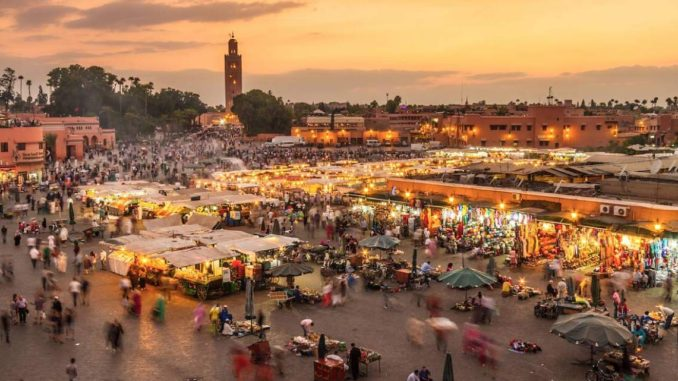Imagine you're standing in the middle of the market at night. Describe what the scene looks like now. Standing in the middle of the market at night, the scene is transformed into a dazzling display of sights and sounds. The square is illuminated by countless lanterns and lights from the stalls, casting a warm, inviting glow over the entire area. The crowd is still dense, but the pace feels more relaxed as people slowly wander from stall to stall. The air is filled with the sounds of animated haggling, cheerful conversations, and the occasional burst of laughter. Street performers now have a more prominent presence, with musicians playing traditional tunes and dancers engaging crowds. The aroma of freshly cooked street food is even more pronounced, mingling with the cooler night air. The Koutoubia Mosque's minaret stands tall in the distance, beautifully lit, providing a calming and majestic backdrop to the vibrant market life. 